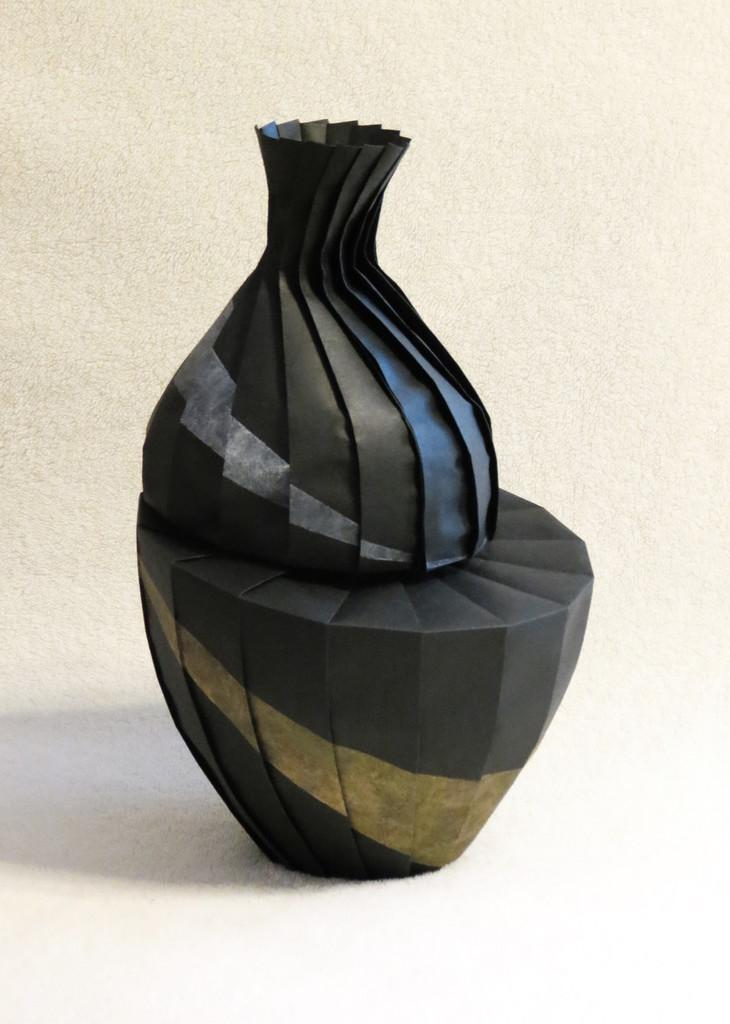What type of vase is present in the image? There is a paper vase in the image. Where is the paper vase located? The paper vase is kept on a table. What type of soup is being served in the paper vase in the image? There is no soup present in the image; it features a paper vase on a table. Can you tell me how many judges are sitting near the paper vase in the image? There are no judges present in the image; it only features a paper vase on a table. 